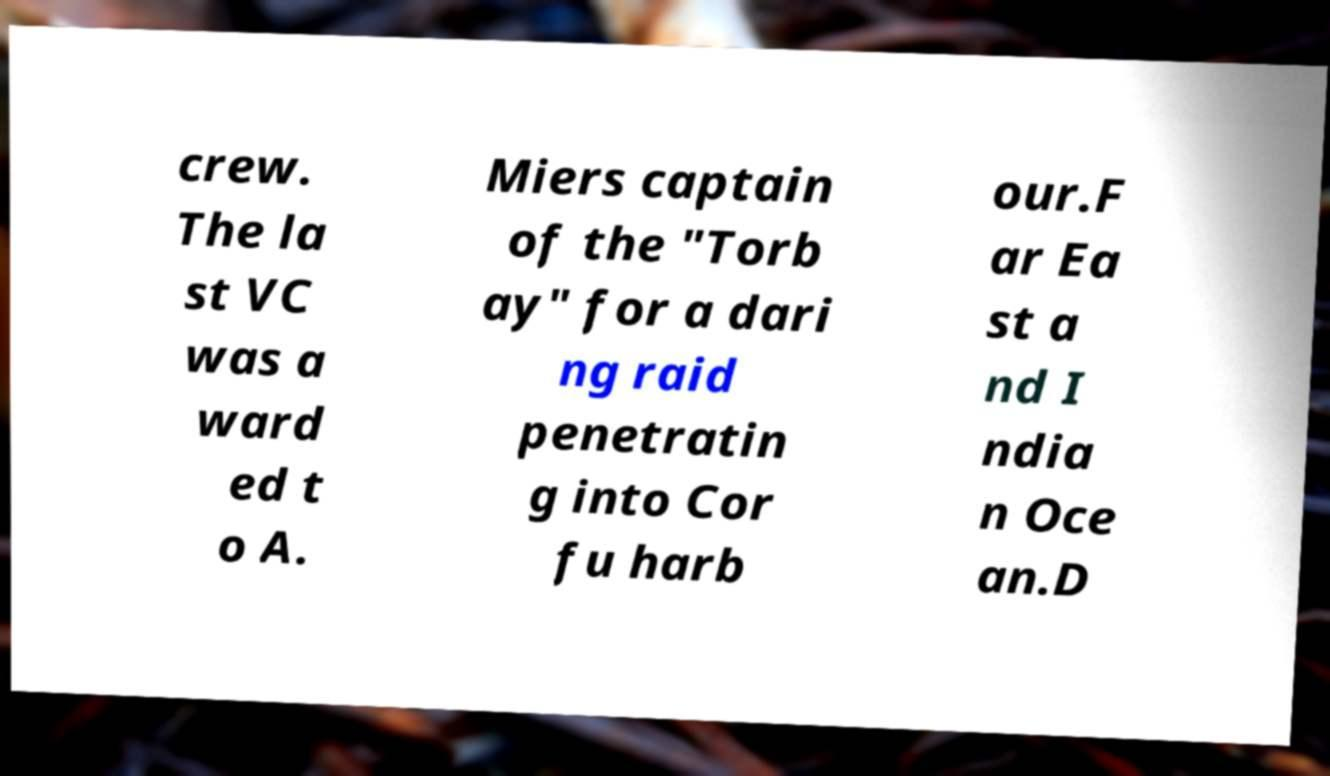Could you assist in decoding the text presented in this image and type it out clearly? crew. The la st VC was a ward ed t o A. Miers captain of the "Torb ay" for a dari ng raid penetratin g into Cor fu harb our.F ar Ea st a nd I ndia n Oce an.D 